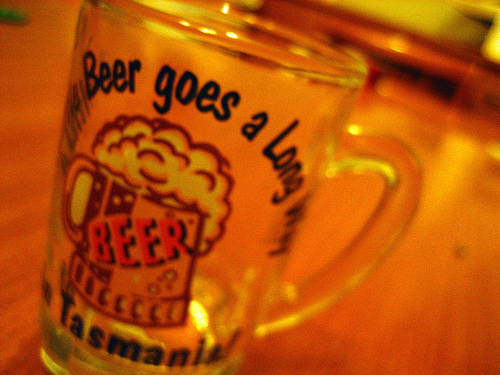<image>
Can you confirm if the glass is on the table? Yes. Looking at the image, I can see the glass is positioned on top of the table, with the table providing support. Is the fake glass in front of the actual glass? No. The fake glass is not in front of the actual glass. The spatial positioning shows a different relationship between these objects. 